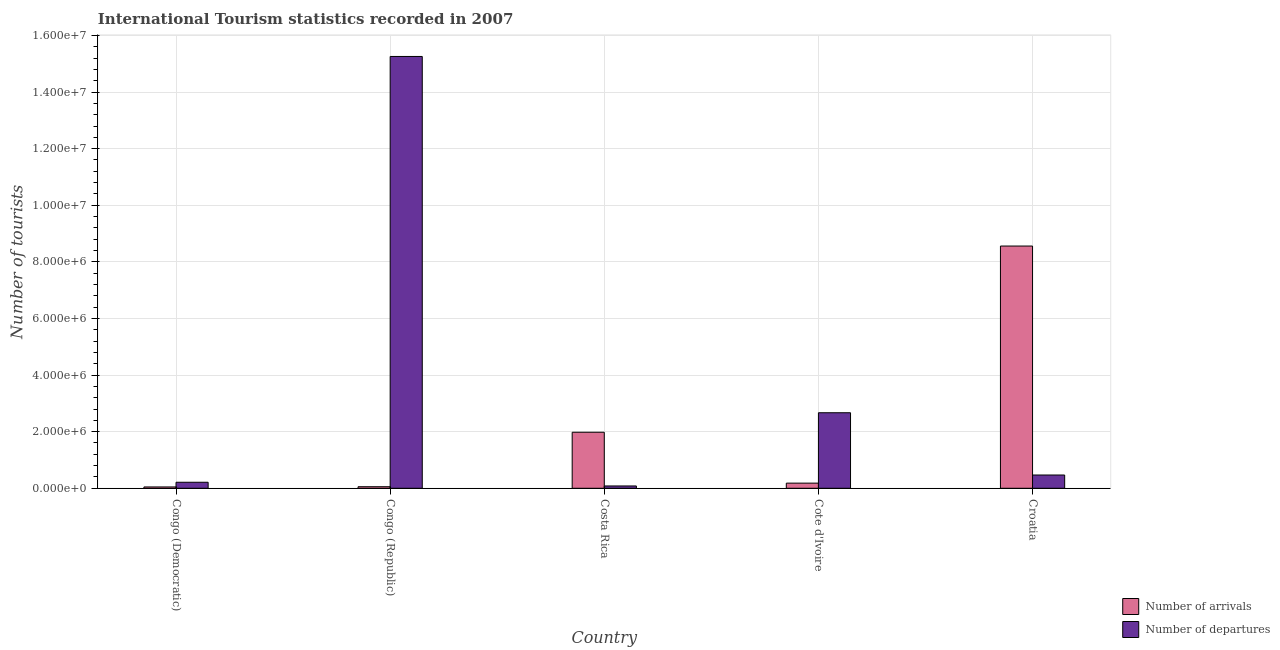How many groups of bars are there?
Provide a short and direct response. 5. Are the number of bars on each tick of the X-axis equal?
Offer a terse response. Yes. How many bars are there on the 4th tick from the left?
Keep it short and to the point. 2. How many bars are there on the 2nd tick from the right?
Offer a very short reply. 2. What is the label of the 4th group of bars from the left?
Offer a very short reply. Cote d'Ivoire. In how many cases, is the number of bars for a given country not equal to the number of legend labels?
Give a very brief answer. 0. What is the number of tourist arrivals in Costa Rica?
Provide a succinct answer. 1.98e+06. Across all countries, what is the maximum number of tourist arrivals?
Ensure brevity in your answer.  8.56e+06. Across all countries, what is the minimum number of tourist arrivals?
Give a very brief answer. 4.70e+04. In which country was the number of tourist departures maximum?
Your response must be concise. Congo (Republic). In which country was the number of tourist departures minimum?
Offer a terse response. Costa Rica. What is the total number of tourist departures in the graph?
Offer a terse response. 1.87e+07. What is the difference between the number of tourist arrivals in Congo (Republic) and that in Cote d'Ivoire?
Your answer should be very brief. -1.27e+05. What is the difference between the number of tourist arrivals in Congo (Democratic) and the number of tourist departures in Cote d'Ivoire?
Offer a very short reply. -2.62e+06. What is the average number of tourist arrivals per country?
Your answer should be very brief. 2.16e+06. What is the difference between the number of tourist arrivals and number of tourist departures in Croatia?
Keep it short and to the point. 8.09e+06. What is the ratio of the number of tourist departures in Congo (Democratic) to that in Congo (Republic)?
Keep it short and to the point. 0.01. What is the difference between the highest and the second highest number of tourist arrivals?
Give a very brief answer. 6.58e+06. What is the difference between the highest and the lowest number of tourist arrivals?
Offer a terse response. 8.51e+06. In how many countries, is the number of tourist departures greater than the average number of tourist departures taken over all countries?
Your answer should be very brief. 1. What does the 2nd bar from the left in Croatia represents?
Offer a very short reply. Number of departures. What does the 2nd bar from the right in Congo (Republic) represents?
Give a very brief answer. Number of arrivals. How many bars are there?
Your response must be concise. 10. Are all the bars in the graph horizontal?
Provide a succinct answer. No. How many countries are there in the graph?
Your answer should be very brief. 5. Are the values on the major ticks of Y-axis written in scientific E-notation?
Offer a terse response. Yes. Does the graph contain any zero values?
Make the answer very short. No. Does the graph contain grids?
Your answer should be compact. Yes. How are the legend labels stacked?
Offer a very short reply. Vertical. What is the title of the graph?
Keep it short and to the point. International Tourism statistics recorded in 2007. Does "Measles" appear as one of the legend labels in the graph?
Your answer should be very brief. No. What is the label or title of the X-axis?
Make the answer very short. Country. What is the label or title of the Y-axis?
Your answer should be very brief. Number of tourists. What is the Number of tourists of Number of arrivals in Congo (Democratic)?
Make the answer very short. 4.70e+04. What is the Number of tourists of Number of departures in Congo (Democratic)?
Your answer should be compact. 2.13e+05. What is the Number of tourists in Number of arrivals in Congo (Republic)?
Make the answer very short. 5.50e+04. What is the Number of tourists in Number of departures in Congo (Republic)?
Your answer should be very brief. 1.53e+07. What is the Number of tourists in Number of arrivals in Costa Rica?
Offer a very short reply. 1.98e+06. What is the Number of tourists of Number of departures in Costa Rica?
Ensure brevity in your answer.  8.20e+04. What is the Number of tourists of Number of arrivals in Cote d'Ivoire?
Your response must be concise. 1.82e+05. What is the Number of tourists of Number of departures in Cote d'Ivoire?
Offer a very short reply. 2.67e+06. What is the Number of tourists in Number of arrivals in Croatia?
Provide a succinct answer. 8.56e+06. What is the Number of tourists in Number of departures in Croatia?
Your answer should be compact. 4.69e+05. Across all countries, what is the maximum Number of tourists of Number of arrivals?
Provide a succinct answer. 8.56e+06. Across all countries, what is the maximum Number of tourists of Number of departures?
Provide a succinct answer. 1.53e+07. Across all countries, what is the minimum Number of tourists in Number of arrivals?
Your response must be concise. 4.70e+04. Across all countries, what is the minimum Number of tourists in Number of departures?
Offer a terse response. 8.20e+04. What is the total Number of tourists in Number of arrivals in the graph?
Ensure brevity in your answer.  1.08e+07. What is the total Number of tourists in Number of departures in the graph?
Keep it short and to the point. 1.87e+07. What is the difference between the Number of tourists in Number of arrivals in Congo (Democratic) and that in Congo (Republic)?
Offer a very short reply. -8000. What is the difference between the Number of tourists in Number of departures in Congo (Democratic) and that in Congo (Republic)?
Provide a succinct answer. -1.50e+07. What is the difference between the Number of tourists in Number of arrivals in Congo (Democratic) and that in Costa Rica?
Provide a succinct answer. -1.93e+06. What is the difference between the Number of tourists in Number of departures in Congo (Democratic) and that in Costa Rica?
Your response must be concise. 1.31e+05. What is the difference between the Number of tourists in Number of arrivals in Congo (Democratic) and that in Cote d'Ivoire?
Offer a terse response. -1.35e+05. What is the difference between the Number of tourists of Number of departures in Congo (Democratic) and that in Cote d'Ivoire?
Give a very brief answer. -2.46e+06. What is the difference between the Number of tourists in Number of arrivals in Congo (Democratic) and that in Croatia?
Your answer should be compact. -8.51e+06. What is the difference between the Number of tourists in Number of departures in Congo (Democratic) and that in Croatia?
Your response must be concise. -2.56e+05. What is the difference between the Number of tourists in Number of arrivals in Congo (Republic) and that in Costa Rica?
Offer a very short reply. -1.92e+06. What is the difference between the Number of tourists of Number of departures in Congo (Republic) and that in Costa Rica?
Make the answer very short. 1.52e+07. What is the difference between the Number of tourists in Number of arrivals in Congo (Republic) and that in Cote d'Ivoire?
Offer a very short reply. -1.27e+05. What is the difference between the Number of tourists of Number of departures in Congo (Republic) and that in Cote d'Ivoire?
Offer a very short reply. 1.26e+07. What is the difference between the Number of tourists of Number of arrivals in Congo (Republic) and that in Croatia?
Offer a terse response. -8.50e+06. What is the difference between the Number of tourists in Number of departures in Congo (Republic) and that in Croatia?
Make the answer very short. 1.48e+07. What is the difference between the Number of tourists of Number of arrivals in Costa Rica and that in Cote d'Ivoire?
Keep it short and to the point. 1.80e+06. What is the difference between the Number of tourists of Number of departures in Costa Rica and that in Cote d'Ivoire?
Give a very brief answer. -2.59e+06. What is the difference between the Number of tourists of Number of arrivals in Costa Rica and that in Croatia?
Your response must be concise. -6.58e+06. What is the difference between the Number of tourists in Number of departures in Costa Rica and that in Croatia?
Provide a succinct answer. -3.87e+05. What is the difference between the Number of tourists of Number of arrivals in Cote d'Ivoire and that in Croatia?
Offer a very short reply. -8.38e+06. What is the difference between the Number of tourists in Number of departures in Cote d'Ivoire and that in Croatia?
Keep it short and to the point. 2.20e+06. What is the difference between the Number of tourists in Number of arrivals in Congo (Democratic) and the Number of tourists in Number of departures in Congo (Republic)?
Your answer should be compact. -1.52e+07. What is the difference between the Number of tourists in Number of arrivals in Congo (Democratic) and the Number of tourists in Number of departures in Costa Rica?
Offer a very short reply. -3.50e+04. What is the difference between the Number of tourists in Number of arrivals in Congo (Democratic) and the Number of tourists in Number of departures in Cote d'Ivoire?
Provide a succinct answer. -2.62e+06. What is the difference between the Number of tourists in Number of arrivals in Congo (Democratic) and the Number of tourists in Number of departures in Croatia?
Your answer should be very brief. -4.22e+05. What is the difference between the Number of tourists of Number of arrivals in Congo (Republic) and the Number of tourists of Number of departures in Costa Rica?
Ensure brevity in your answer.  -2.70e+04. What is the difference between the Number of tourists in Number of arrivals in Congo (Republic) and the Number of tourists in Number of departures in Cote d'Ivoire?
Keep it short and to the point. -2.61e+06. What is the difference between the Number of tourists in Number of arrivals in Congo (Republic) and the Number of tourists in Number of departures in Croatia?
Your answer should be very brief. -4.14e+05. What is the difference between the Number of tourists in Number of arrivals in Costa Rica and the Number of tourists in Number of departures in Cote d'Ivoire?
Your answer should be very brief. -6.89e+05. What is the difference between the Number of tourists in Number of arrivals in Costa Rica and the Number of tourists in Number of departures in Croatia?
Your response must be concise. 1.51e+06. What is the difference between the Number of tourists in Number of arrivals in Cote d'Ivoire and the Number of tourists in Number of departures in Croatia?
Your answer should be very brief. -2.87e+05. What is the average Number of tourists in Number of arrivals per country?
Your answer should be very brief. 2.16e+06. What is the average Number of tourists of Number of departures per country?
Provide a succinct answer. 3.74e+06. What is the difference between the Number of tourists in Number of arrivals and Number of tourists in Number of departures in Congo (Democratic)?
Ensure brevity in your answer.  -1.66e+05. What is the difference between the Number of tourists of Number of arrivals and Number of tourists of Number of departures in Congo (Republic)?
Ensure brevity in your answer.  -1.52e+07. What is the difference between the Number of tourists of Number of arrivals and Number of tourists of Number of departures in Costa Rica?
Your answer should be compact. 1.90e+06. What is the difference between the Number of tourists of Number of arrivals and Number of tourists of Number of departures in Cote d'Ivoire?
Make the answer very short. -2.49e+06. What is the difference between the Number of tourists in Number of arrivals and Number of tourists in Number of departures in Croatia?
Offer a very short reply. 8.09e+06. What is the ratio of the Number of tourists of Number of arrivals in Congo (Democratic) to that in Congo (Republic)?
Offer a terse response. 0.85. What is the ratio of the Number of tourists of Number of departures in Congo (Democratic) to that in Congo (Republic)?
Your answer should be very brief. 0.01. What is the ratio of the Number of tourists of Number of arrivals in Congo (Democratic) to that in Costa Rica?
Offer a very short reply. 0.02. What is the ratio of the Number of tourists in Number of departures in Congo (Democratic) to that in Costa Rica?
Make the answer very short. 2.6. What is the ratio of the Number of tourists of Number of arrivals in Congo (Democratic) to that in Cote d'Ivoire?
Your answer should be very brief. 0.26. What is the ratio of the Number of tourists of Number of departures in Congo (Democratic) to that in Cote d'Ivoire?
Ensure brevity in your answer.  0.08. What is the ratio of the Number of tourists in Number of arrivals in Congo (Democratic) to that in Croatia?
Make the answer very short. 0.01. What is the ratio of the Number of tourists of Number of departures in Congo (Democratic) to that in Croatia?
Keep it short and to the point. 0.45. What is the ratio of the Number of tourists in Number of arrivals in Congo (Republic) to that in Costa Rica?
Keep it short and to the point. 0.03. What is the ratio of the Number of tourists in Number of departures in Congo (Republic) to that in Costa Rica?
Your answer should be compact. 186.06. What is the ratio of the Number of tourists of Number of arrivals in Congo (Republic) to that in Cote d'Ivoire?
Provide a short and direct response. 0.3. What is the ratio of the Number of tourists in Number of departures in Congo (Republic) to that in Cote d'Ivoire?
Make the answer very short. 5.72. What is the ratio of the Number of tourists in Number of arrivals in Congo (Republic) to that in Croatia?
Ensure brevity in your answer.  0.01. What is the ratio of the Number of tourists of Number of departures in Congo (Republic) to that in Croatia?
Your answer should be compact. 32.53. What is the ratio of the Number of tourists of Number of arrivals in Costa Rica to that in Cote d'Ivoire?
Offer a terse response. 10.88. What is the ratio of the Number of tourists of Number of departures in Costa Rica to that in Cote d'Ivoire?
Your response must be concise. 0.03. What is the ratio of the Number of tourists of Number of arrivals in Costa Rica to that in Croatia?
Give a very brief answer. 0.23. What is the ratio of the Number of tourists of Number of departures in Costa Rica to that in Croatia?
Provide a short and direct response. 0.17. What is the ratio of the Number of tourists in Number of arrivals in Cote d'Ivoire to that in Croatia?
Your response must be concise. 0.02. What is the ratio of the Number of tourists of Number of departures in Cote d'Ivoire to that in Croatia?
Provide a short and direct response. 5.69. What is the difference between the highest and the second highest Number of tourists in Number of arrivals?
Ensure brevity in your answer.  6.58e+06. What is the difference between the highest and the second highest Number of tourists of Number of departures?
Offer a very short reply. 1.26e+07. What is the difference between the highest and the lowest Number of tourists in Number of arrivals?
Keep it short and to the point. 8.51e+06. What is the difference between the highest and the lowest Number of tourists in Number of departures?
Keep it short and to the point. 1.52e+07. 